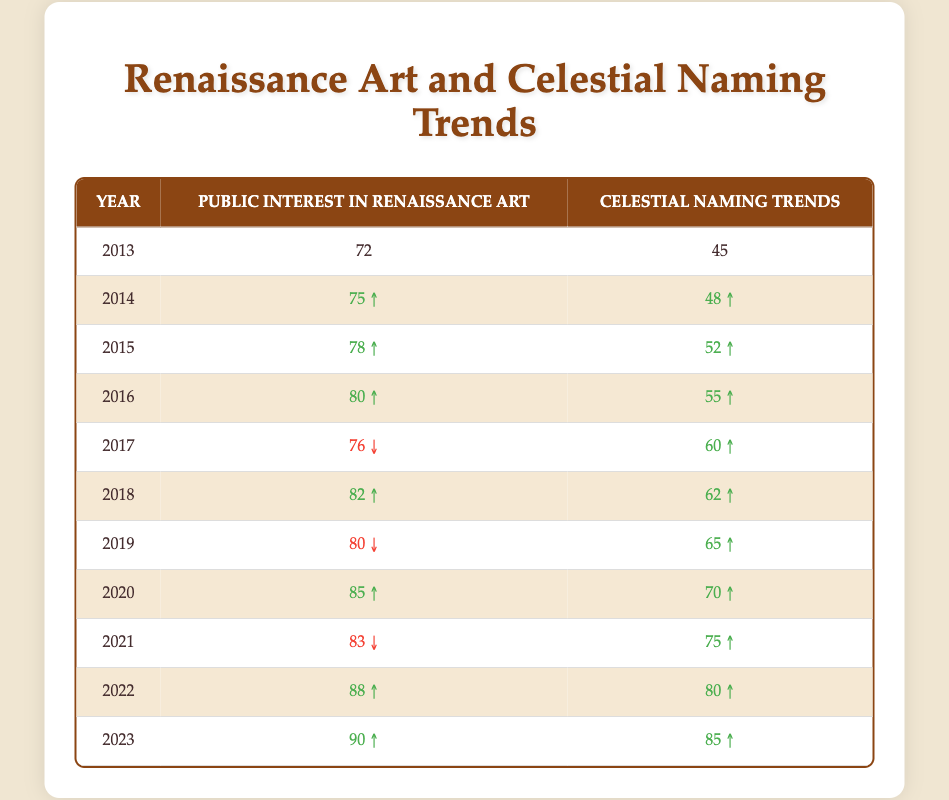What was the public interest in Renaissance art in 2016? By referring to the table, in the year 2016, the value listed under "Public Interest in Renaissance Art" is 80.
Answer: 80 What was the lowest recorded public interest in Renaissance art during the decade? Looking through the "Public Interest in Renaissance Art" column, the lowest value appears in 2013, which is 72.
Answer: 72 In which year did celestial naming trends exceed public interest in Renaissance art? Analyzing the values in both columns, the celestial naming trends first exceed public interest in Renaissance art in 2017, where they are 60 and 76, respectively.
Answer: 2017 What is the average public interest in Renaissance art over the last decade? Adding all the values from the "Public Interest in Renaissance Art" column (72 + 75 + 78 + 80 + 76 + 82 + 80 + 85 + 83 + 88 + 90 =  78.55). Dividing by the number of years (11), the average is 80.
Answer: 80 Did celestial naming trends consistently increase every year from 2013 to 2023? By examining the table, it's evident that celestial naming trends did not increase every year. For instance, the trend decreased from 80 in 2019 to 83 in 2021 before increasing again. Hence, the statement is false.
Answer: No Is there a year when the increase in public interest in Renaissance art was greater than that in celestial naming trends? By reviewing the table closely, the year 2016 shows an increase of 4 in public interest (from 78 to 80) while celestial naming trends increased by only 3 (from 52 to 55). Therefore, it is true that a greater increase occurred in 2016 for public interest.
Answer: Yes What was the percentage increase in public interest in Renaissance art from 2013 to 2023? To calculate this, first find the difference between the two values (90 - 72 = 18) then divide by the original value (72) and multiply by 100 for percentage (18/72 * 100 = 25%). Thus, the percentage increase is approximately 25%.
Answer: 25% What trend can be observed for celestial naming trends in regards to the years 2015 to 2023? Observing the table data, the trends clearly show a consistent upward trajectory from 52 in 2015, leading to 85 in 2023, indicating steady growth over these years.
Answer: Consistently increasing 